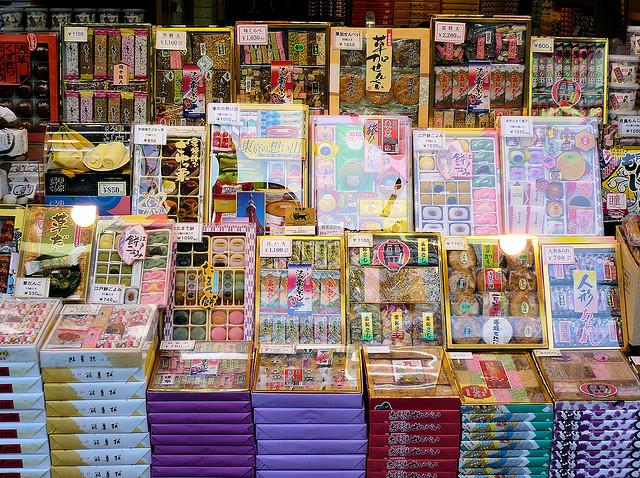Why are the boxes lined up and on display?

Choices:
A) to donate
B) to clean
C) to sell
D) as art to sell 